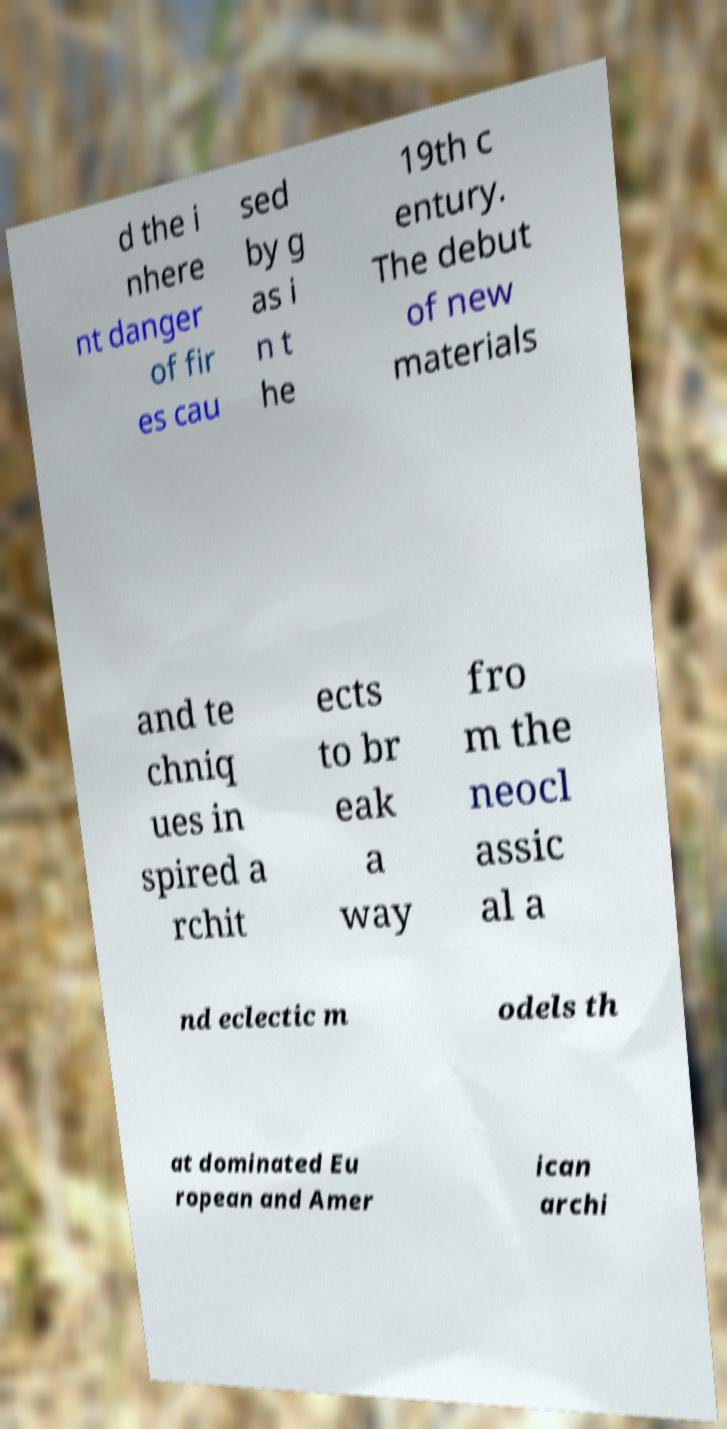Can you read and provide the text displayed in the image?This photo seems to have some interesting text. Can you extract and type it out for me? d the i nhere nt danger of fir es cau sed by g as i n t he 19th c entury. The debut of new materials and te chniq ues in spired a rchit ects to br eak a way fro m the neocl assic al a nd eclectic m odels th at dominated Eu ropean and Amer ican archi 